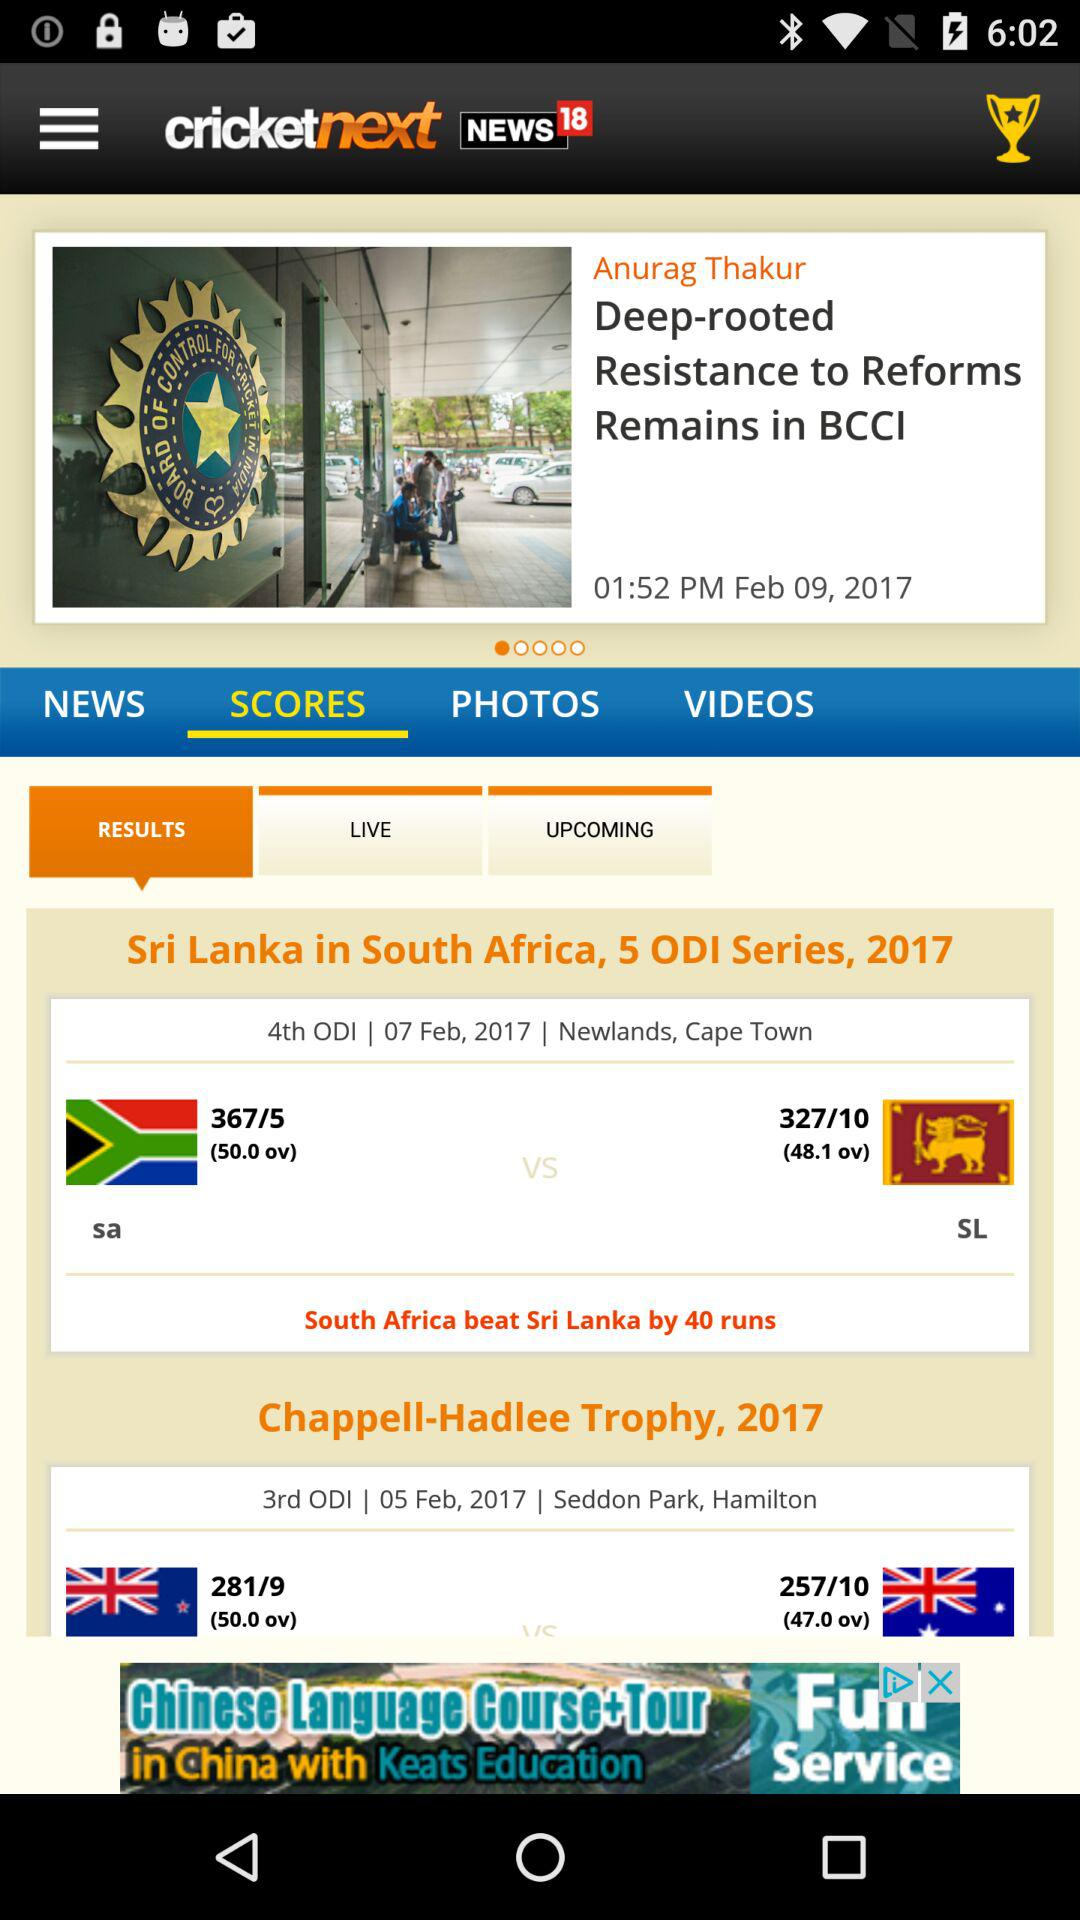What is the application name? The name of the application is "NEWS 18". 